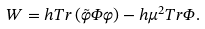Convert formula to latex. <formula><loc_0><loc_0><loc_500><loc_500>W = h T r \left ( \tilde { \varphi } \Phi \varphi \right ) - h \mu ^ { 2 } T r \Phi .</formula> 